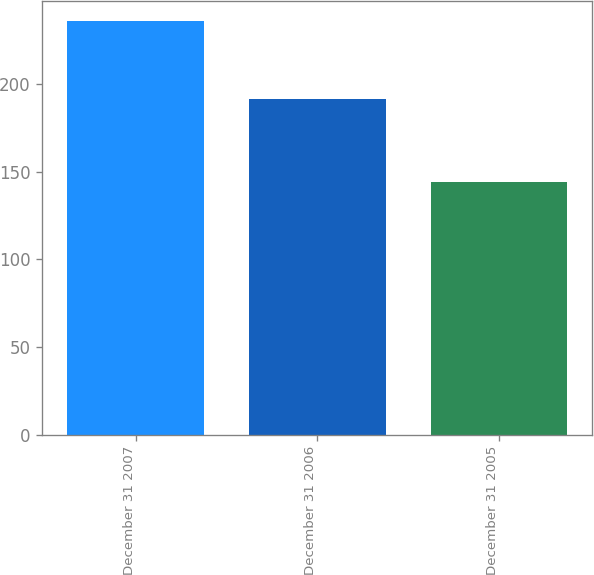Convert chart. <chart><loc_0><loc_0><loc_500><loc_500><bar_chart><fcel>December 31 2007<fcel>December 31 2006<fcel>December 31 2005<nl><fcel>236<fcel>191.4<fcel>144.5<nl></chart> 